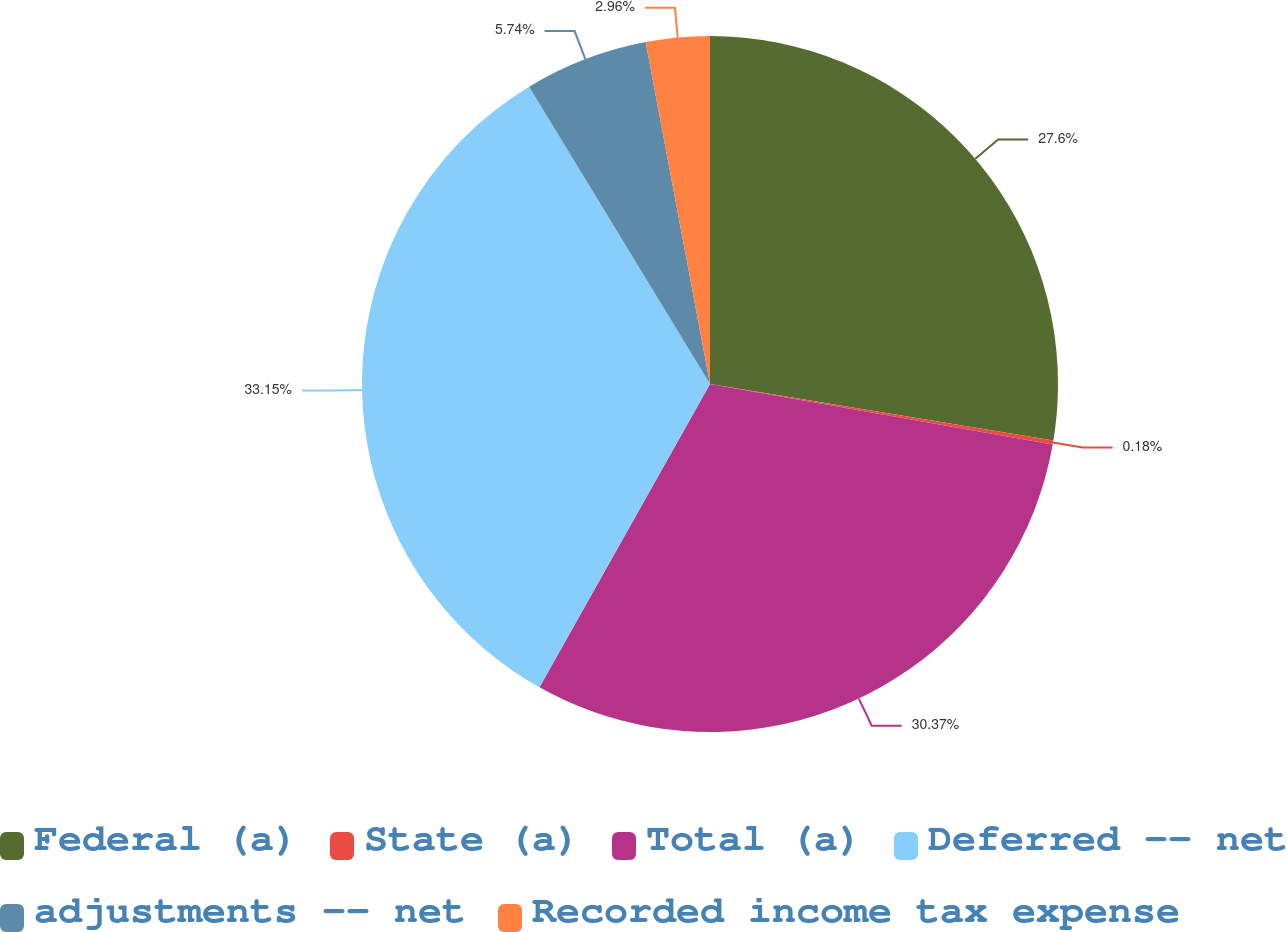Convert chart to OTSL. <chart><loc_0><loc_0><loc_500><loc_500><pie_chart><fcel>Federal (a)<fcel>State (a)<fcel>Total (a)<fcel>Deferred -- net<fcel>adjustments -- net<fcel>Recorded income tax expense<nl><fcel>27.6%<fcel>0.18%<fcel>30.37%<fcel>33.15%<fcel>5.74%<fcel>2.96%<nl></chart> 